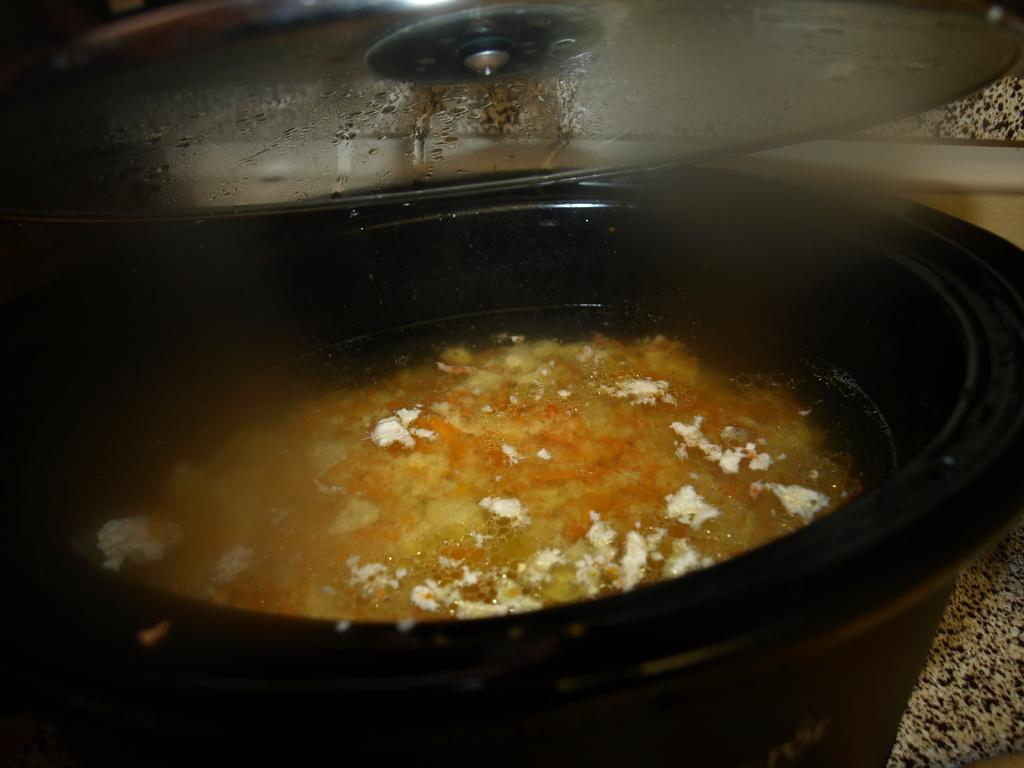What is the main object in the image? There is a dish in the image. What is inside the dish? The dish contains some liquid. What type of nail is being used to create the scene in the image? There is no nail or scene present in the image; it only features a dish with liquid. 